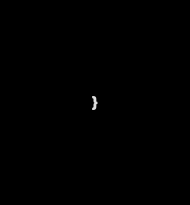Convert code to text. <code><loc_0><loc_0><loc_500><loc_500><_Java_>}
</code> 